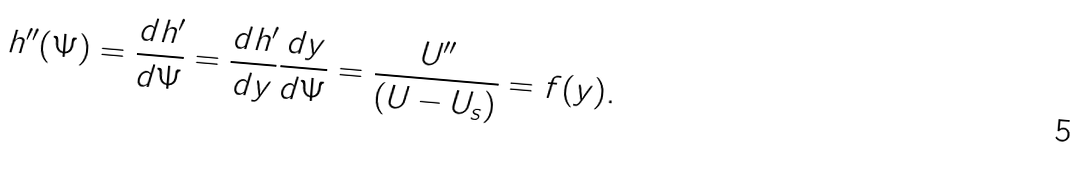<formula> <loc_0><loc_0><loc_500><loc_500>h ^ { \prime \prime } ( \Psi ) = \frac { d h ^ { \prime } } { d \Psi } = \frac { d h ^ { \prime } } { d y } \frac { d y } { d \Psi } = \frac { U ^ { \prime \prime } } { ( U - U _ { s } ) } = f ( y ) .</formula> 